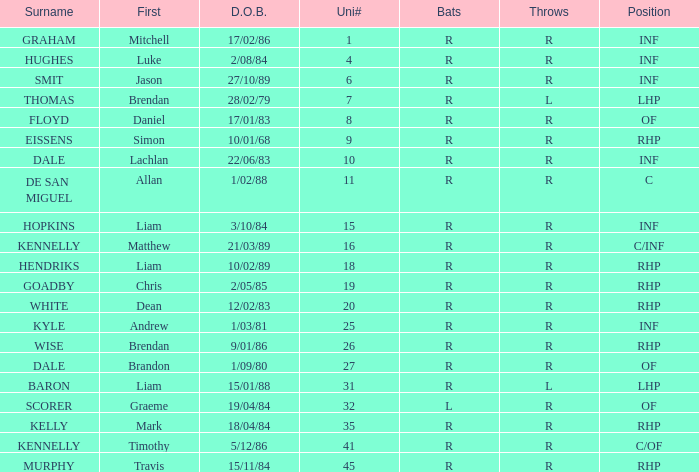Which player has a last name of baron? R. 